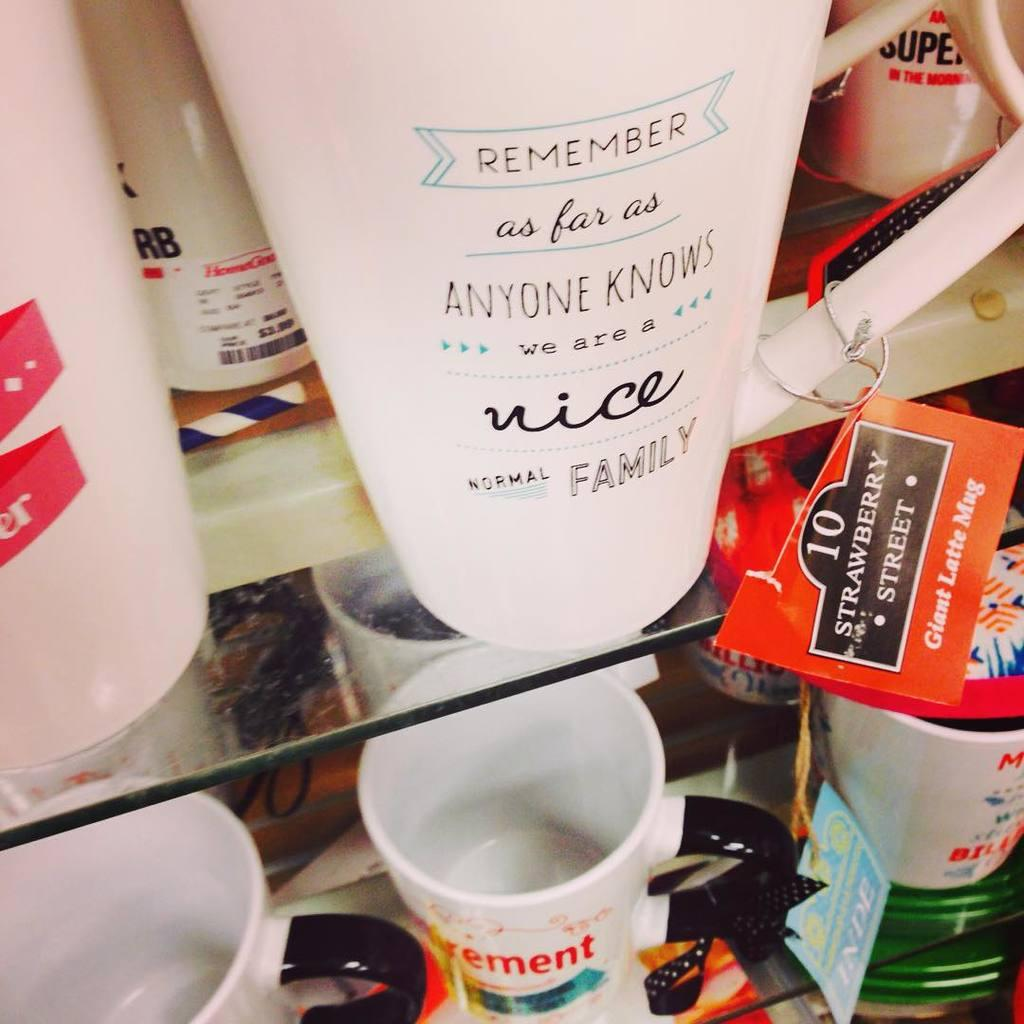<image>
Share a concise interpretation of the image provided. A plastic cup bears a message about a nice normal family. 